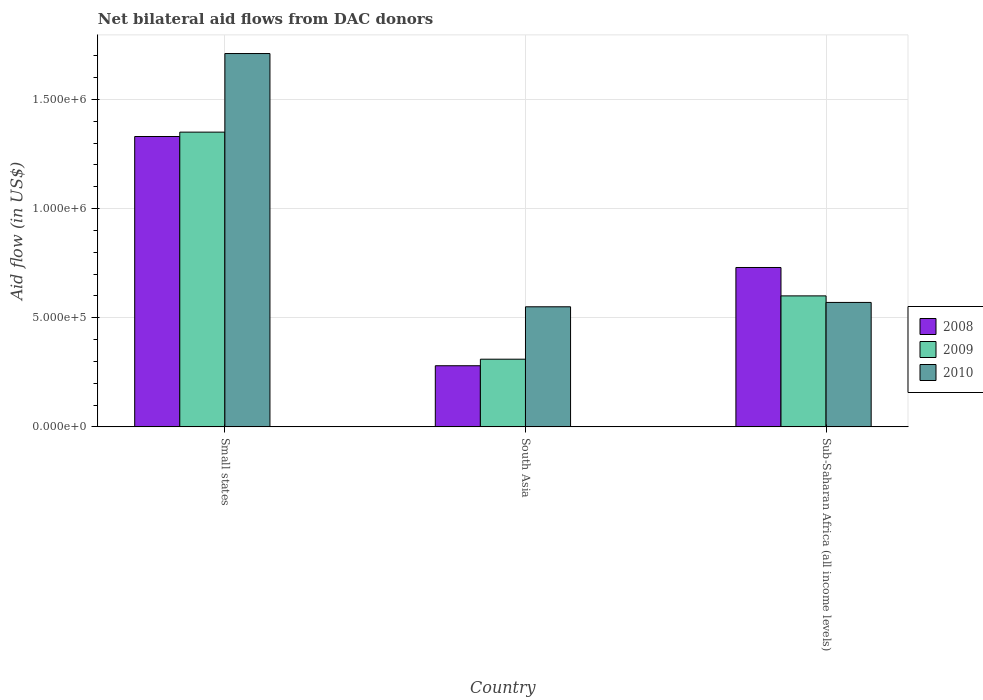How many different coloured bars are there?
Your response must be concise. 3. How many groups of bars are there?
Your response must be concise. 3. How many bars are there on the 1st tick from the left?
Make the answer very short. 3. How many bars are there on the 3rd tick from the right?
Ensure brevity in your answer.  3. What is the label of the 1st group of bars from the left?
Offer a terse response. Small states. In how many cases, is the number of bars for a given country not equal to the number of legend labels?
Offer a very short reply. 0. Across all countries, what is the maximum net bilateral aid flow in 2009?
Your answer should be compact. 1.35e+06. In which country was the net bilateral aid flow in 2010 maximum?
Give a very brief answer. Small states. In which country was the net bilateral aid flow in 2009 minimum?
Offer a terse response. South Asia. What is the total net bilateral aid flow in 2010 in the graph?
Offer a terse response. 2.83e+06. What is the difference between the net bilateral aid flow in 2009 in Small states and that in Sub-Saharan Africa (all income levels)?
Offer a very short reply. 7.50e+05. What is the difference between the net bilateral aid flow in 2009 in Sub-Saharan Africa (all income levels) and the net bilateral aid flow in 2010 in South Asia?
Your response must be concise. 5.00e+04. What is the average net bilateral aid flow in 2008 per country?
Your answer should be compact. 7.80e+05. What is the difference between the net bilateral aid flow of/in 2010 and net bilateral aid flow of/in 2008 in Sub-Saharan Africa (all income levels)?
Your response must be concise. -1.60e+05. In how many countries, is the net bilateral aid flow in 2008 greater than 300000 US$?
Give a very brief answer. 2. What is the ratio of the net bilateral aid flow in 2008 in Small states to that in Sub-Saharan Africa (all income levels)?
Provide a succinct answer. 1.82. Is the net bilateral aid flow in 2008 in Small states less than that in Sub-Saharan Africa (all income levels)?
Provide a short and direct response. No. Is the difference between the net bilateral aid flow in 2010 in Small states and South Asia greater than the difference between the net bilateral aid flow in 2008 in Small states and South Asia?
Provide a short and direct response. Yes. What is the difference between the highest and the second highest net bilateral aid flow in 2008?
Provide a short and direct response. 6.00e+05. What is the difference between the highest and the lowest net bilateral aid flow in 2010?
Offer a very short reply. 1.16e+06. In how many countries, is the net bilateral aid flow in 2008 greater than the average net bilateral aid flow in 2008 taken over all countries?
Your response must be concise. 1. What does the 2nd bar from the left in Small states represents?
Provide a succinct answer. 2009. Is it the case that in every country, the sum of the net bilateral aid flow in 2010 and net bilateral aid flow in 2008 is greater than the net bilateral aid flow in 2009?
Make the answer very short. Yes. How many countries are there in the graph?
Provide a succinct answer. 3. What is the difference between two consecutive major ticks on the Y-axis?
Your response must be concise. 5.00e+05. Are the values on the major ticks of Y-axis written in scientific E-notation?
Provide a succinct answer. Yes. Where does the legend appear in the graph?
Offer a very short reply. Center right. How are the legend labels stacked?
Keep it short and to the point. Vertical. What is the title of the graph?
Your response must be concise. Net bilateral aid flows from DAC donors. What is the label or title of the X-axis?
Offer a very short reply. Country. What is the label or title of the Y-axis?
Make the answer very short. Aid flow (in US$). What is the Aid flow (in US$) of 2008 in Small states?
Provide a succinct answer. 1.33e+06. What is the Aid flow (in US$) in 2009 in Small states?
Your answer should be very brief. 1.35e+06. What is the Aid flow (in US$) in 2010 in Small states?
Make the answer very short. 1.71e+06. What is the Aid flow (in US$) of 2010 in South Asia?
Keep it short and to the point. 5.50e+05. What is the Aid flow (in US$) in 2008 in Sub-Saharan Africa (all income levels)?
Ensure brevity in your answer.  7.30e+05. What is the Aid flow (in US$) of 2009 in Sub-Saharan Africa (all income levels)?
Provide a short and direct response. 6.00e+05. What is the Aid flow (in US$) in 2010 in Sub-Saharan Africa (all income levels)?
Make the answer very short. 5.70e+05. Across all countries, what is the maximum Aid flow (in US$) of 2008?
Provide a succinct answer. 1.33e+06. Across all countries, what is the maximum Aid flow (in US$) of 2009?
Give a very brief answer. 1.35e+06. Across all countries, what is the maximum Aid flow (in US$) in 2010?
Your answer should be compact. 1.71e+06. Across all countries, what is the minimum Aid flow (in US$) of 2009?
Make the answer very short. 3.10e+05. Across all countries, what is the minimum Aid flow (in US$) of 2010?
Provide a succinct answer. 5.50e+05. What is the total Aid flow (in US$) of 2008 in the graph?
Make the answer very short. 2.34e+06. What is the total Aid flow (in US$) of 2009 in the graph?
Your response must be concise. 2.26e+06. What is the total Aid flow (in US$) of 2010 in the graph?
Provide a succinct answer. 2.83e+06. What is the difference between the Aid flow (in US$) of 2008 in Small states and that in South Asia?
Your response must be concise. 1.05e+06. What is the difference between the Aid flow (in US$) of 2009 in Small states and that in South Asia?
Ensure brevity in your answer.  1.04e+06. What is the difference between the Aid flow (in US$) in 2010 in Small states and that in South Asia?
Give a very brief answer. 1.16e+06. What is the difference between the Aid flow (in US$) of 2008 in Small states and that in Sub-Saharan Africa (all income levels)?
Your response must be concise. 6.00e+05. What is the difference between the Aid flow (in US$) of 2009 in Small states and that in Sub-Saharan Africa (all income levels)?
Provide a short and direct response. 7.50e+05. What is the difference between the Aid flow (in US$) in 2010 in Small states and that in Sub-Saharan Africa (all income levels)?
Provide a short and direct response. 1.14e+06. What is the difference between the Aid flow (in US$) of 2008 in South Asia and that in Sub-Saharan Africa (all income levels)?
Provide a short and direct response. -4.50e+05. What is the difference between the Aid flow (in US$) in 2009 in South Asia and that in Sub-Saharan Africa (all income levels)?
Provide a succinct answer. -2.90e+05. What is the difference between the Aid flow (in US$) in 2008 in Small states and the Aid flow (in US$) in 2009 in South Asia?
Provide a short and direct response. 1.02e+06. What is the difference between the Aid flow (in US$) in 2008 in Small states and the Aid flow (in US$) in 2010 in South Asia?
Ensure brevity in your answer.  7.80e+05. What is the difference between the Aid flow (in US$) in 2008 in Small states and the Aid flow (in US$) in 2009 in Sub-Saharan Africa (all income levels)?
Provide a succinct answer. 7.30e+05. What is the difference between the Aid flow (in US$) in 2008 in Small states and the Aid flow (in US$) in 2010 in Sub-Saharan Africa (all income levels)?
Offer a terse response. 7.60e+05. What is the difference between the Aid flow (in US$) of 2009 in Small states and the Aid flow (in US$) of 2010 in Sub-Saharan Africa (all income levels)?
Ensure brevity in your answer.  7.80e+05. What is the difference between the Aid flow (in US$) of 2008 in South Asia and the Aid flow (in US$) of 2009 in Sub-Saharan Africa (all income levels)?
Provide a succinct answer. -3.20e+05. What is the difference between the Aid flow (in US$) of 2008 in South Asia and the Aid flow (in US$) of 2010 in Sub-Saharan Africa (all income levels)?
Your answer should be compact. -2.90e+05. What is the difference between the Aid flow (in US$) of 2009 in South Asia and the Aid flow (in US$) of 2010 in Sub-Saharan Africa (all income levels)?
Offer a terse response. -2.60e+05. What is the average Aid flow (in US$) in 2008 per country?
Ensure brevity in your answer.  7.80e+05. What is the average Aid flow (in US$) in 2009 per country?
Keep it short and to the point. 7.53e+05. What is the average Aid flow (in US$) in 2010 per country?
Give a very brief answer. 9.43e+05. What is the difference between the Aid flow (in US$) in 2008 and Aid flow (in US$) in 2009 in Small states?
Your answer should be compact. -2.00e+04. What is the difference between the Aid flow (in US$) of 2008 and Aid flow (in US$) of 2010 in Small states?
Provide a short and direct response. -3.80e+05. What is the difference between the Aid flow (in US$) of 2009 and Aid flow (in US$) of 2010 in Small states?
Give a very brief answer. -3.60e+05. What is the difference between the Aid flow (in US$) in 2008 and Aid flow (in US$) in 2010 in South Asia?
Keep it short and to the point. -2.70e+05. What is the difference between the Aid flow (in US$) in 2009 and Aid flow (in US$) in 2010 in Sub-Saharan Africa (all income levels)?
Ensure brevity in your answer.  3.00e+04. What is the ratio of the Aid flow (in US$) in 2008 in Small states to that in South Asia?
Give a very brief answer. 4.75. What is the ratio of the Aid flow (in US$) in 2009 in Small states to that in South Asia?
Provide a succinct answer. 4.35. What is the ratio of the Aid flow (in US$) of 2010 in Small states to that in South Asia?
Give a very brief answer. 3.11. What is the ratio of the Aid flow (in US$) in 2008 in Small states to that in Sub-Saharan Africa (all income levels)?
Make the answer very short. 1.82. What is the ratio of the Aid flow (in US$) in 2009 in Small states to that in Sub-Saharan Africa (all income levels)?
Offer a very short reply. 2.25. What is the ratio of the Aid flow (in US$) of 2008 in South Asia to that in Sub-Saharan Africa (all income levels)?
Keep it short and to the point. 0.38. What is the ratio of the Aid flow (in US$) of 2009 in South Asia to that in Sub-Saharan Africa (all income levels)?
Keep it short and to the point. 0.52. What is the ratio of the Aid flow (in US$) of 2010 in South Asia to that in Sub-Saharan Africa (all income levels)?
Offer a very short reply. 0.96. What is the difference between the highest and the second highest Aid flow (in US$) in 2009?
Your answer should be compact. 7.50e+05. What is the difference between the highest and the second highest Aid flow (in US$) in 2010?
Offer a very short reply. 1.14e+06. What is the difference between the highest and the lowest Aid flow (in US$) in 2008?
Your response must be concise. 1.05e+06. What is the difference between the highest and the lowest Aid flow (in US$) in 2009?
Give a very brief answer. 1.04e+06. What is the difference between the highest and the lowest Aid flow (in US$) in 2010?
Give a very brief answer. 1.16e+06. 